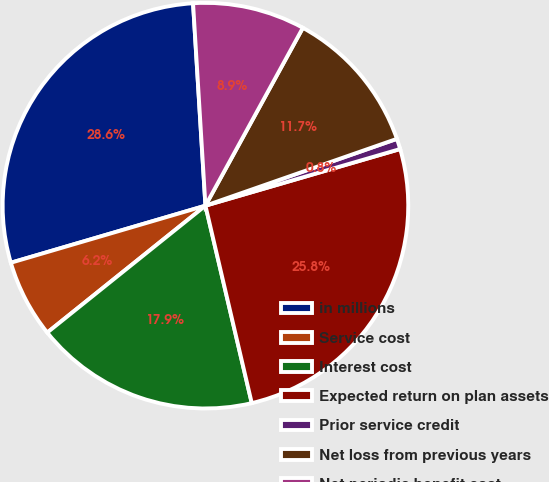Convert chart. <chart><loc_0><loc_0><loc_500><loc_500><pie_chart><fcel>in millions<fcel>Service cost<fcel>Interest cost<fcel>Expected return on plan assets<fcel>Prior service credit<fcel>Net loss from previous years<fcel>Net periodic benefit cost<nl><fcel>28.57%<fcel>6.22%<fcel>17.91%<fcel>25.84%<fcel>0.84%<fcel>11.68%<fcel>8.95%<nl></chart> 